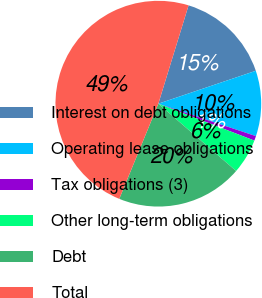Convert chart to OTSL. <chart><loc_0><loc_0><loc_500><loc_500><pie_chart><fcel>Interest on debt obligations<fcel>Operating lease obligations<fcel>Tax obligations (3)<fcel>Other long-term obligations<fcel>Debt<fcel>Total<nl><fcel>15.07%<fcel>10.29%<fcel>0.73%<fcel>5.51%<fcel>19.85%<fcel>48.55%<nl></chart> 